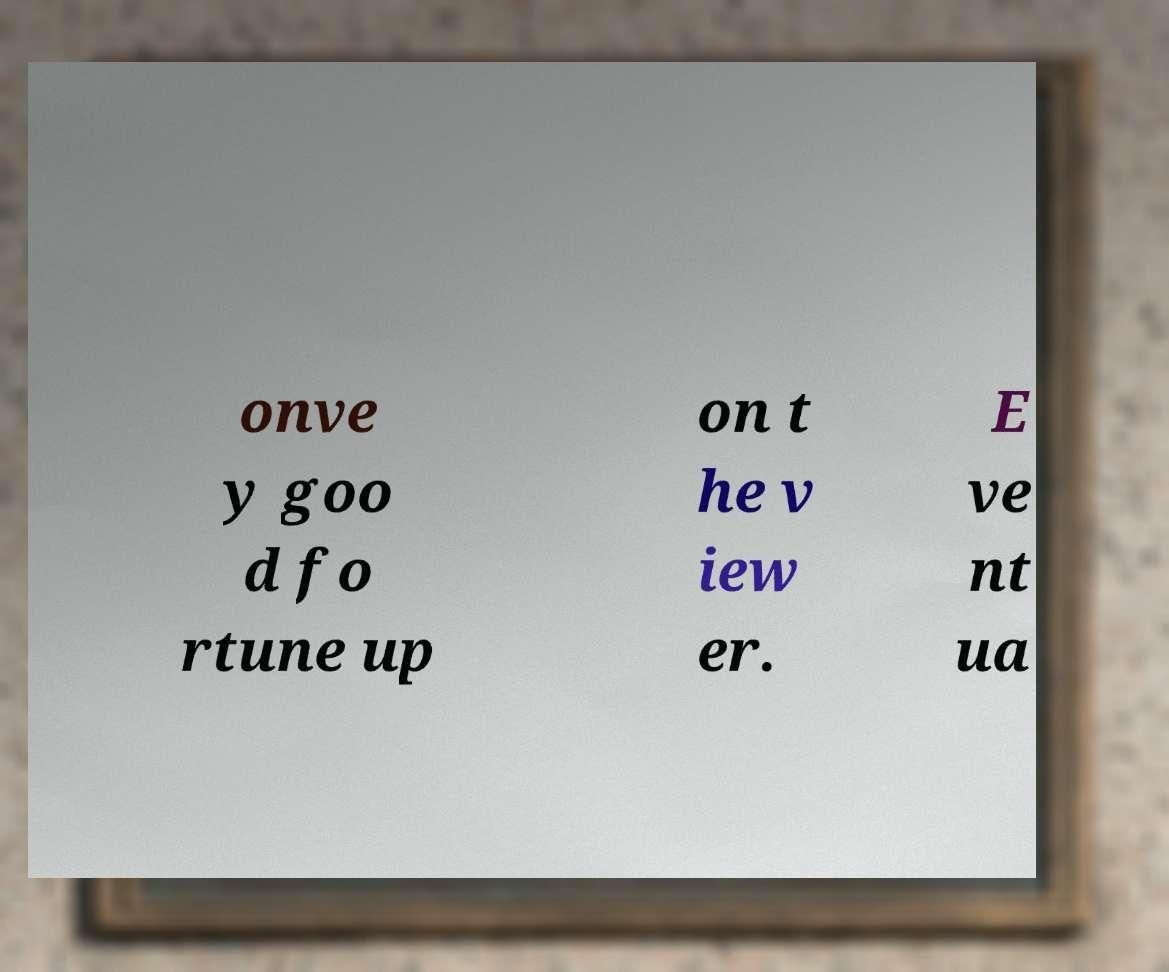Could you assist in decoding the text presented in this image and type it out clearly? onve y goo d fo rtune up on t he v iew er. E ve nt ua 